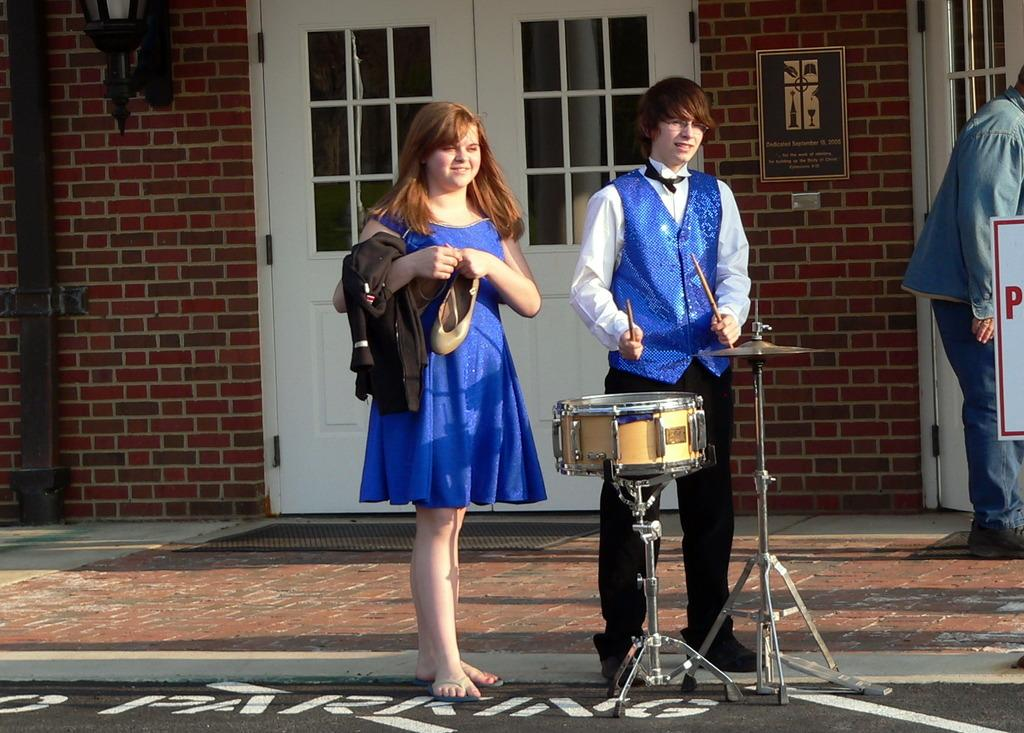How many people are present in the image? There are two people in the image, a woman and a man. What are the woman and the man doing in the image? Both the woman and the man are standing in front of a musical instrument. What can be seen in the background of the image? There is a door, a wall, a lamp, and a person standing in the background of the image. Can you tell me how many umbrellas are visible in the image? There are no umbrellas visible in the image. What type of chin is present on the person standing in the background of the image? There is no chin visible in the image, as it is not possible to see the person's face. 